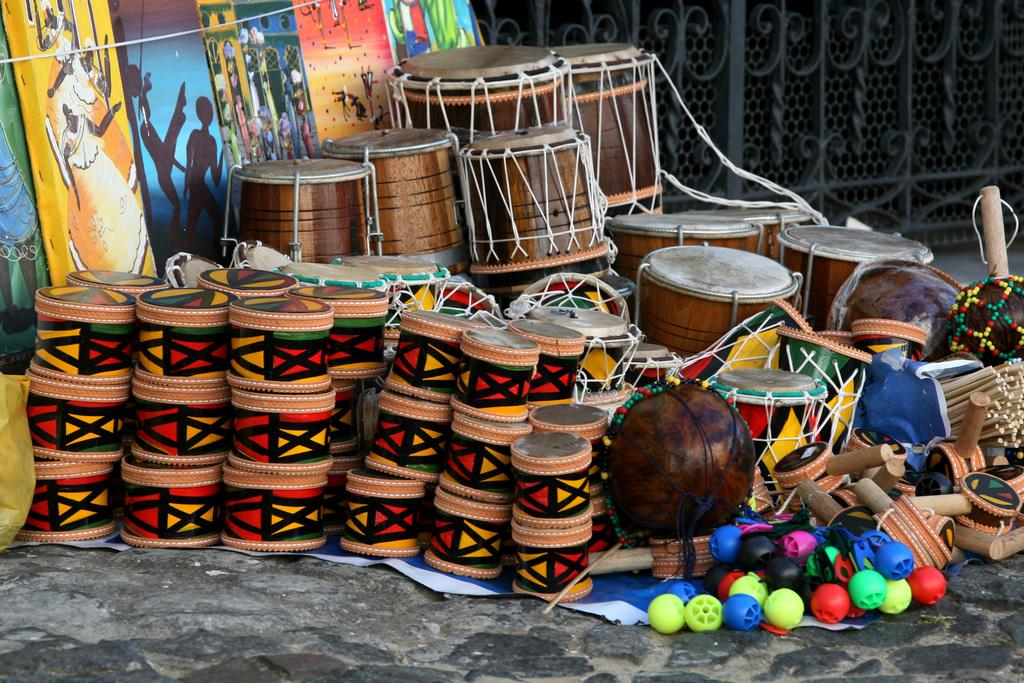What musical instruments are present in the image? There are drums in the image. What type of artwork can be seen in the image? There are paintings in the image. What architectural feature is visible in the background of the image? There is a fencing in the background of the image. What type of kite is being flown by the farmer in the image? There is no kite or farmer present in the image; it features drums, paintings, and a fencing. 